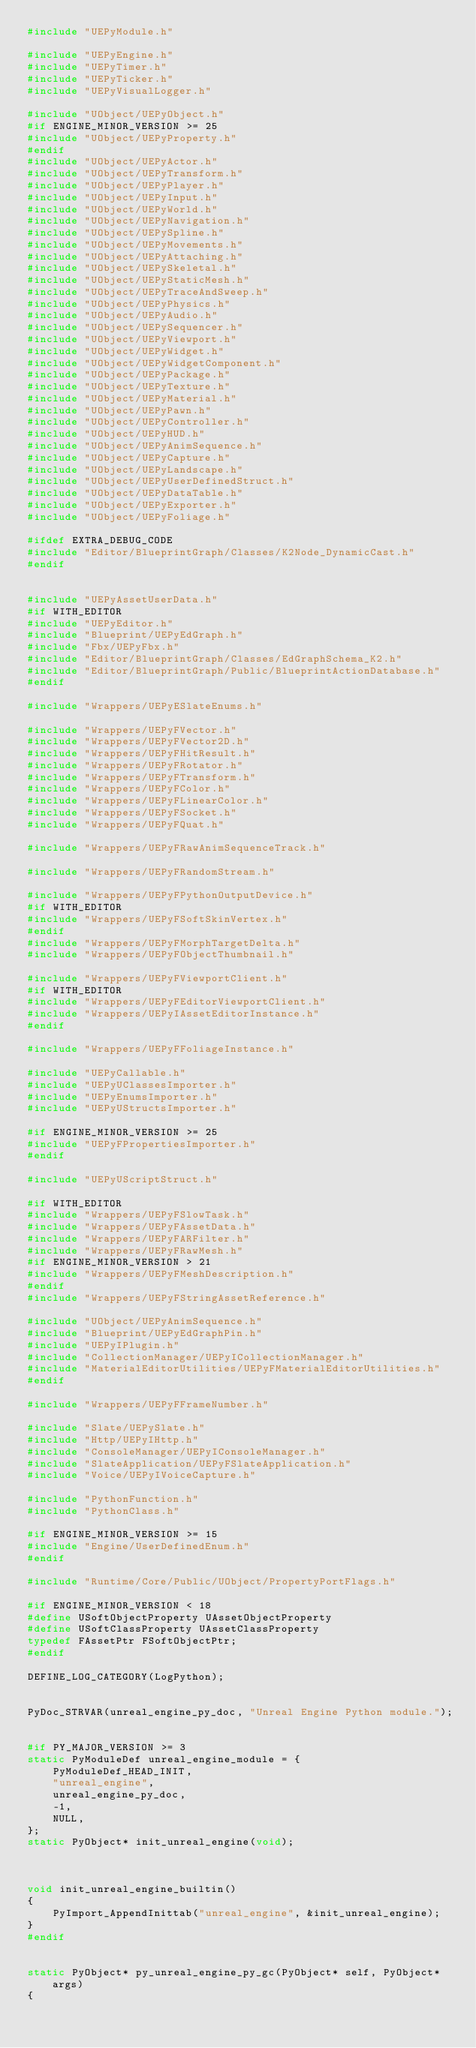<code> <loc_0><loc_0><loc_500><loc_500><_C++_>#include "UEPyModule.h"

#include "UEPyEngine.h"
#include "UEPyTimer.h"
#include "UEPyTicker.h"
#include "UEPyVisualLogger.h"

#include "UObject/UEPyObject.h"
#if ENGINE_MINOR_VERSION >= 25
#include "UObject/UEPyProperty.h"
#endif
#include "UObject/UEPyActor.h"
#include "UObject/UEPyTransform.h"
#include "UObject/UEPyPlayer.h"
#include "UObject/UEPyInput.h"
#include "UObject/UEPyWorld.h"
#include "UObject/UEPyNavigation.h"
#include "UObject/UEPySpline.h"
#include "UObject/UEPyMovements.h"
#include "UObject/UEPyAttaching.h"
#include "UObject/UEPySkeletal.h"
#include "UObject/UEPyStaticMesh.h"
#include "UObject/UEPyTraceAndSweep.h"
#include "UObject/UEPyPhysics.h"
#include "UObject/UEPyAudio.h"
#include "UObject/UEPySequencer.h"
#include "UObject/UEPyViewport.h"
#include "UObject/UEPyWidget.h"
#include "UObject/UEPyWidgetComponent.h"
#include "UObject/UEPyPackage.h"
#include "UObject/UEPyTexture.h"
#include "UObject/UEPyMaterial.h"
#include "UObject/UEPyPawn.h"
#include "UObject/UEPyController.h"
#include "UObject/UEPyHUD.h"
#include "UObject/UEPyAnimSequence.h"
#include "UObject/UEPyCapture.h"
#include "UObject/UEPyLandscape.h"
#include "UObject/UEPyUserDefinedStruct.h"
#include "UObject/UEPyDataTable.h"
#include "UObject/UEPyExporter.h"
#include "UObject/UEPyFoliage.h"

#ifdef EXTRA_DEBUG_CODE
#include "Editor/BlueprintGraph/Classes/K2Node_DynamicCast.h"
#endif


#include "UEPyAssetUserData.h"
#if WITH_EDITOR
#include "UEPyEditor.h"
#include "Blueprint/UEPyEdGraph.h"
#include "Fbx/UEPyFbx.h"
#include "Editor/BlueprintGraph/Classes/EdGraphSchema_K2.h"
#include "Editor/BlueprintGraph/Public/BlueprintActionDatabase.h"
#endif

#include "Wrappers/UEPyESlateEnums.h"

#include "Wrappers/UEPyFVector.h"
#include "Wrappers/UEPyFVector2D.h"
#include "Wrappers/UEPyFHitResult.h"
#include "Wrappers/UEPyFRotator.h"
#include "Wrappers/UEPyFTransform.h"
#include "Wrappers/UEPyFColor.h"
#include "Wrappers/UEPyFLinearColor.h"
#include "Wrappers/UEPyFSocket.h"
#include "Wrappers/UEPyFQuat.h"

#include "Wrappers/UEPyFRawAnimSequenceTrack.h"

#include "Wrappers/UEPyFRandomStream.h"

#include "Wrappers/UEPyFPythonOutputDevice.h"
#if WITH_EDITOR
#include "Wrappers/UEPyFSoftSkinVertex.h"
#endif
#include "Wrappers/UEPyFMorphTargetDelta.h"
#include "Wrappers/UEPyFObjectThumbnail.h"

#include "Wrappers/UEPyFViewportClient.h"
#if WITH_EDITOR
#include "Wrappers/UEPyFEditorViewportClient.h"
#include "Wrappers/UEPyIAssetEditorInstance.h"
#endif

#include "Wrappers/UEPyFFoliageInstance.h"

#include "UEPyCallable.h"
#include "UEPyUClassesImporter.h"
#include "UEPyEnumsImporter.h"
#include "UEPyUStructsImporter.h"

#if ENGINE_MINOR_VERSION >= 25
#include "UEPyFPropertiesImporter.h"
#endif

#include "UEPyUScriptStruct.h"

#if WITH_EDITOR
#include "Wrappers/UEPyFSlowTask.h"
#include "Wrappers/UEPyFAssetData.h"
#include "Wrappers/UEPyFARFilter.h"
#include "Wrappers/UEPyFRawMesh.h"
#if ENGINE_MINOR_VERSION > 21
#include "Wrappers/UEPyFMeshDescription.h"
#endif
#include "Wrappers/UEPyFStringAssetReference.h"

#include "UObject/UEPyAnimSequence.h"
#include "Blueprint/UEPyEdGraphPin.h"
#include "UEPyIPlugin.h"
#include "CollectionManager/UEPyICollectionManager.h"
#include "MaterialEditorUtilities/UEPyFMaterialEditorUtilities.h"
#endif

#include "Wrappers/UEPyFFrameNumber.h"

#include "Slate/UEPySlate.h"
#include "Http/UEPyIHttp.h"
#include "ConsoleManager/UEPyIConsoleManager.h"
#include "SlateApplication/UEPyFSlateApplication.h"
#include "Voice/UEPyIVoiceCapture.h"

#include "PythonFunction.h"
#include "PythonClass.h"

#if ENGINE_MINOR_VERSION >= 15
#include "Engine/UserDefinedEnum.h"
#endif

#include "Runtime/Core/Public/UObject/PropertyPortFlags.h"

#if ENGINE_MINOR_VERSION < 18
#define USoftObjectProperty UAssetObjectProperty
#define USoftClassProperty UAssetClassProperty
typedef FAssetPtr FSoftObjectPtr;
#endif

DEFINE_LOG_CATEGORY(LogPython);


PyDoc_STRVAR(unreal_engine_py_doc, "Unreal Engine Python module.");


#if PY_MAJOR_VERSION >= 3
static PyModuleDef unreal_engine_module = {
	PyModuleDef_HEAD_INIT,
	"unreal_engine",
	unreal_engine_py_doc,
	-1,
	NULL,
};
static PyObject* init_unreal_engine(void);



void init_unreal_engine_builtin()
{
	PyImport_AppendInittab("unreal_engine", &init_unreal_engine);
}
#endif


static PyObject* py_unreal_engine_py_gc(PyObject* self, PyObject* args)
{</code> 